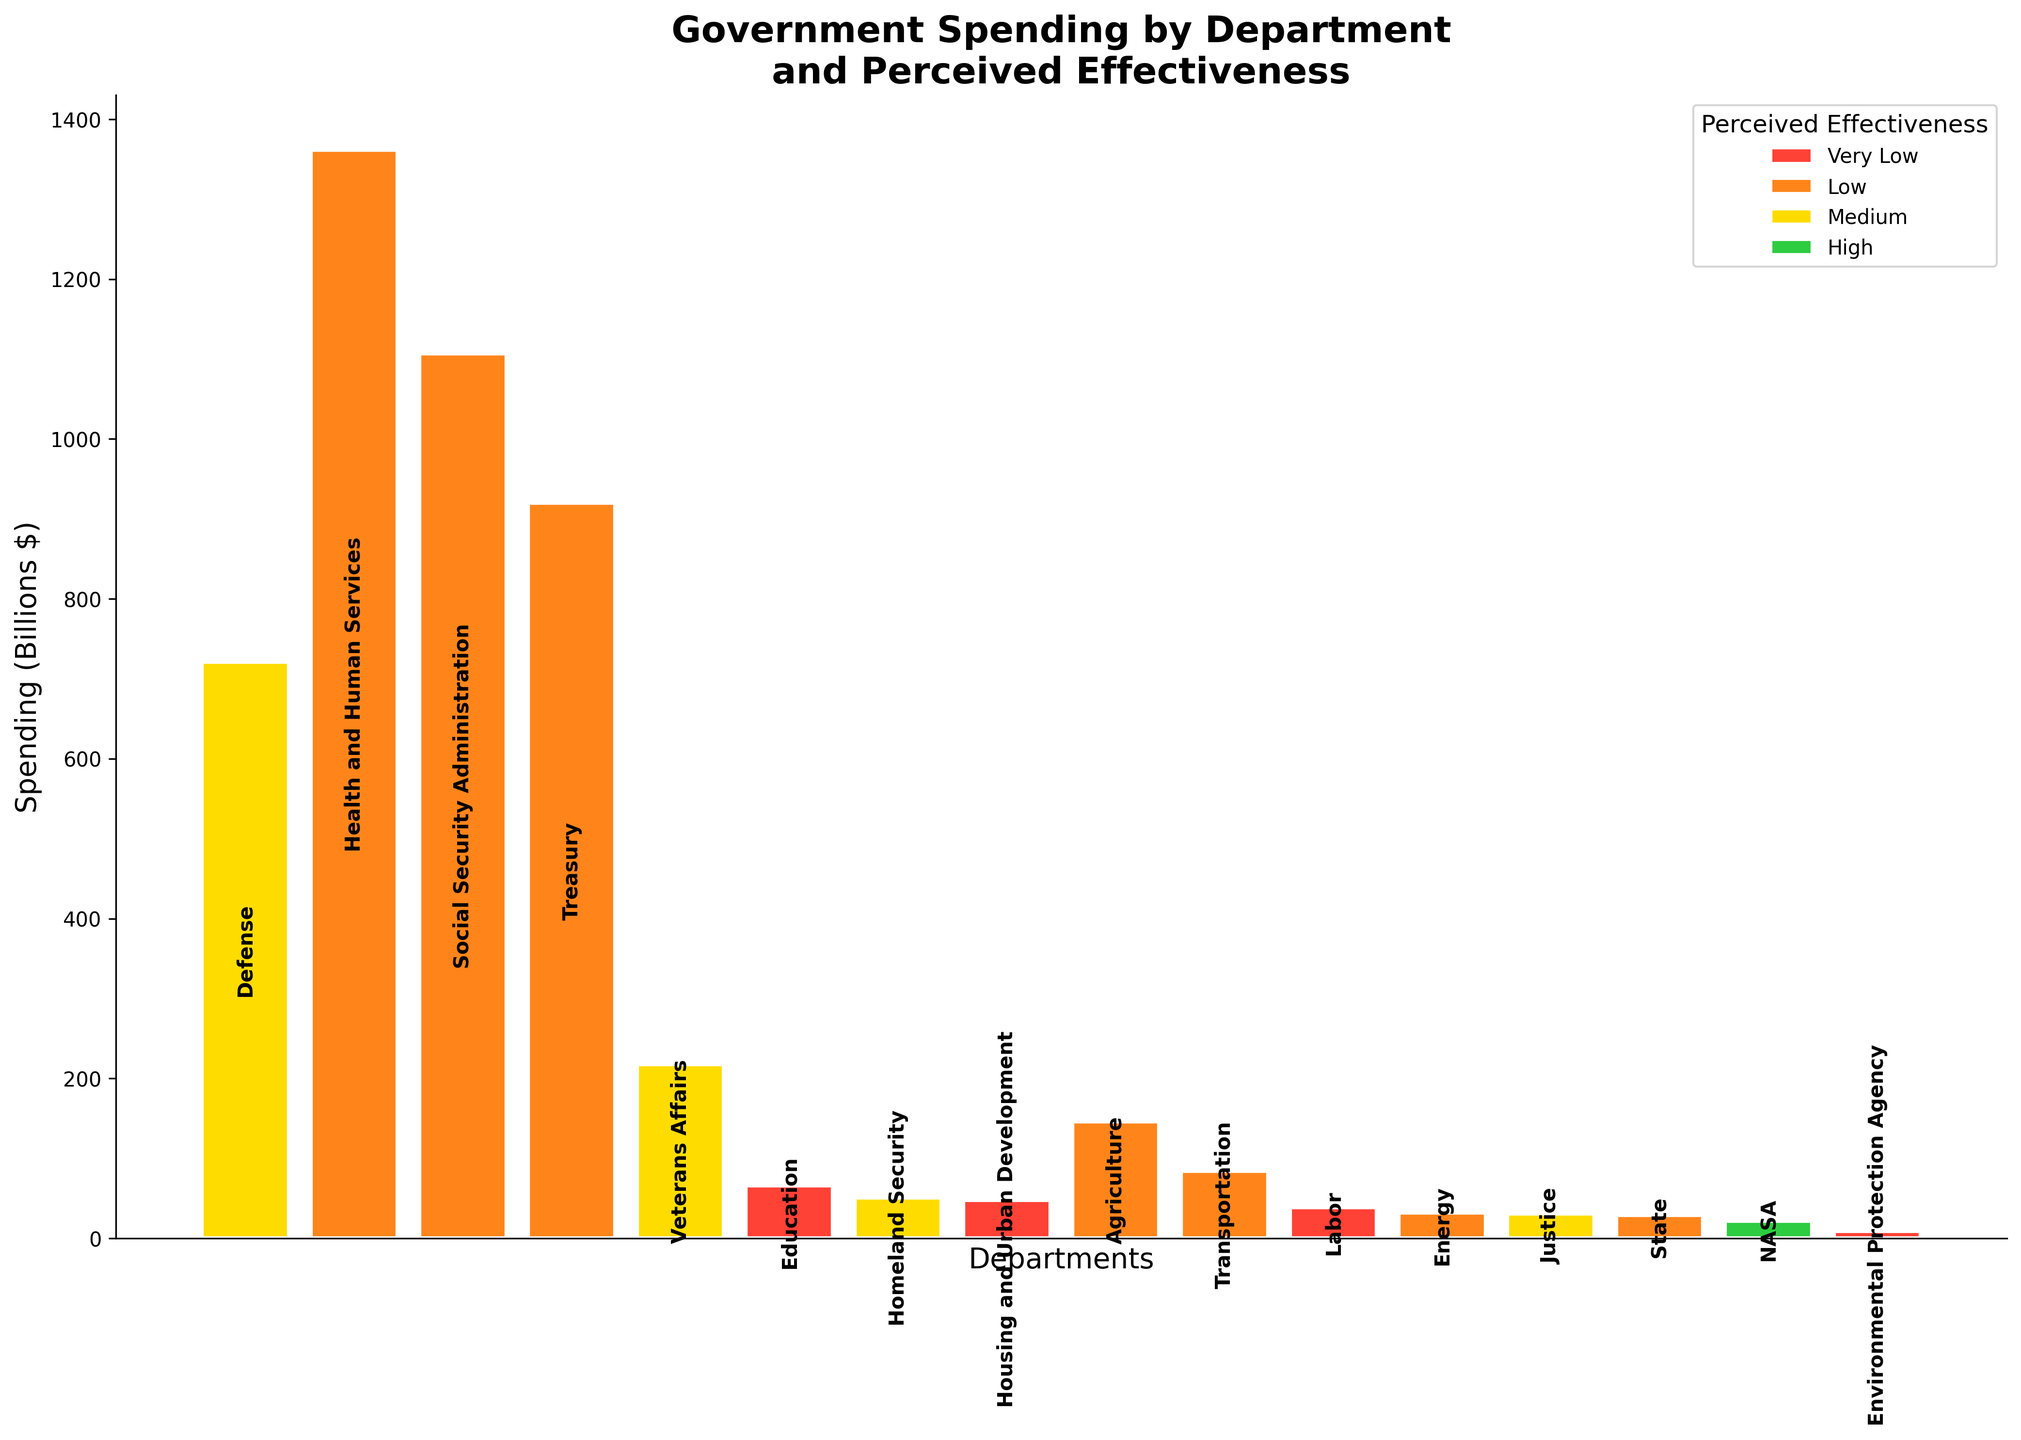How much is the total spending for departments with 'Medium' perceived effectiveness? Sum the spending of departments labeled 'Medium': Defense (721), Veterans Affairs (218), Homeland Security (51), and Justice (31). Total = 721 + 218 + 51 + 31 = 1021 billion dollars.
Answer: 1021 billion dollars Which department has the highest spending and what is its perceived effectiveness? Identify the department with the largest spending: Health and Human Services (1362 billion dollars). Its perceived effectiveness is 'Low'.
Answer: Health and Human Services, Low How does the spending of the Department of Education compare to the Department of Defense? Find the spending for both: Education (66) and Defense (721). Compare: 721 is significantly higher than 66.
Answer: Defense spends significantly more than Education What is the perceived effectiveness of the department with the lowest spending? Look for the department with the smallest spending: Environmental Protection Agency (9 billion dollars). Its perceived effectiveness is 'Very Low'.
Answer: Very Low Are there any departments with 'High' perceived effectiveness? If so, name them. Scan the plot for departments with 'High' effectiveness. Only NASA has 'High' perceived effectiveness.
Answer: NASA What is the combined spending of all departments with 'Very Low' perceived effectiveness? Sum the spending of departments labeled 'Very Low': Education (66), Housing and Urban Development (48), Labor (39), and Environmental Protection Agency (9). Total = 66 + 48 + 39 + 9 = 162 billion dollars.
Answer: 162 billion dollars Which department has lower spending: Transportation or Agriculture, and what is their perceived effectiveness? Compare spending: Transportation (84 billion) and Agriculture (146 billion). Transportation has lower spending. Their perceived effectiveness is both 'Low'.
Answer: Transportation, Low How many departments have 'Low' perceived effectiveness? Count the departments labeled 'Low': Health and Human Services, Social Security Administration, Treasury, Agriculture, Transportation, State, and Energy. There are seven such departments.
Answer: 7 What is the difference in spending between the department with the highest spending and the department with 'High' perceived effectiveness? Identify spending for Health and Human Services (1362 billion) and NASA (22 billion). Compute the difference: 1362 - 22 = 1340 billion dollars.
Answer: 1340 billion dollars 